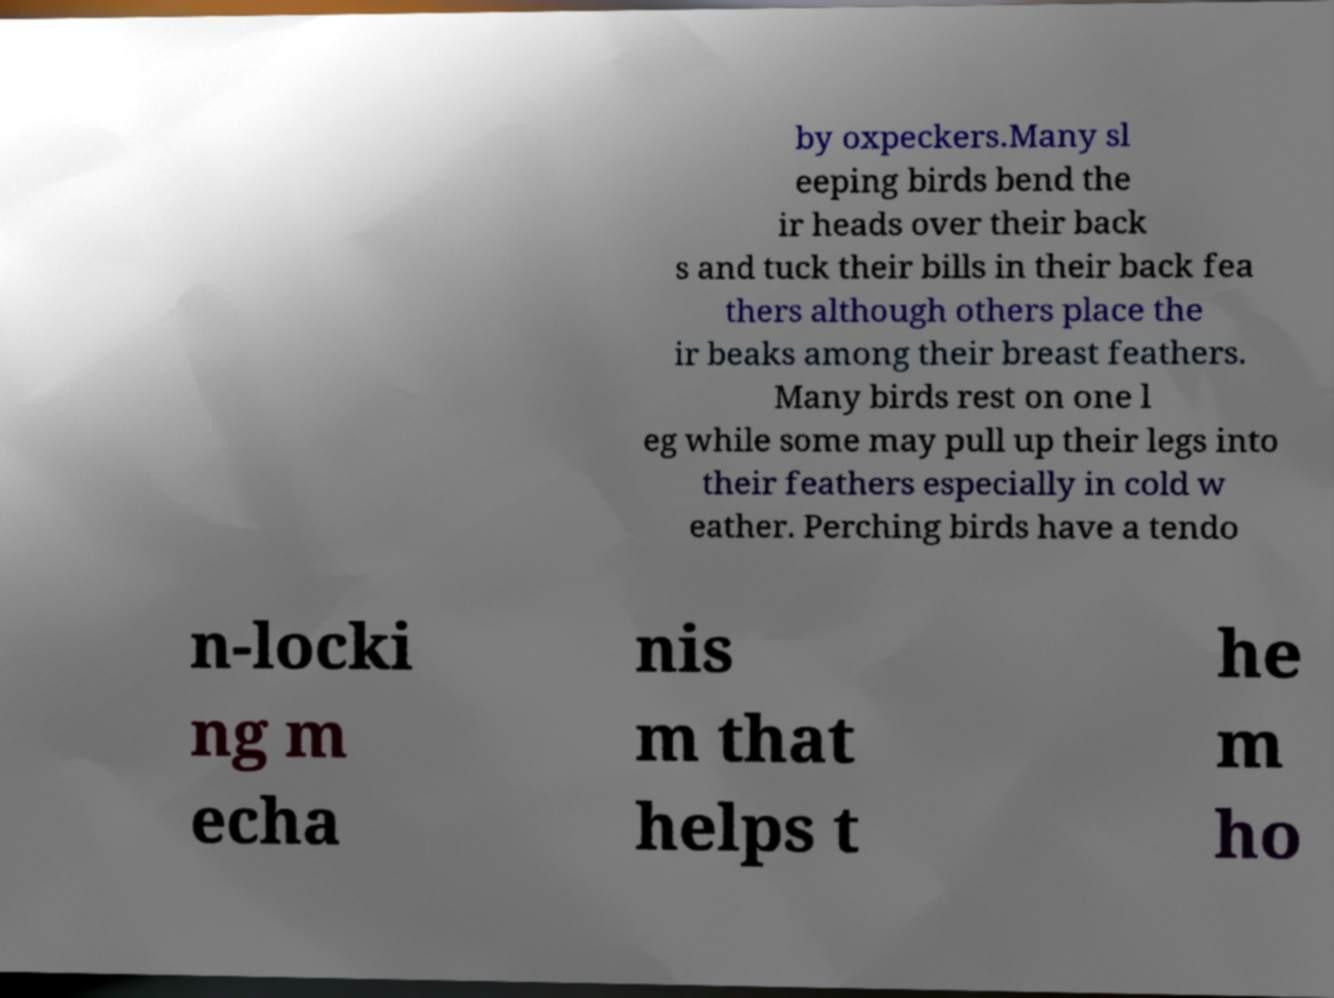What messages or text are displayed in this image? I need them in a readable, typed format. by oxpeckers.Many sl eeping birds bend the ir heads over their back s and tuck their bills in their back fea thers although others place the ir beaks among their breast feathers. Many birds rest on one l eg while some may pull up their legs into their feathers especially in cold w eather. Perching birds have a tendo n-locki ng m echa nis m that helps t he m ho 